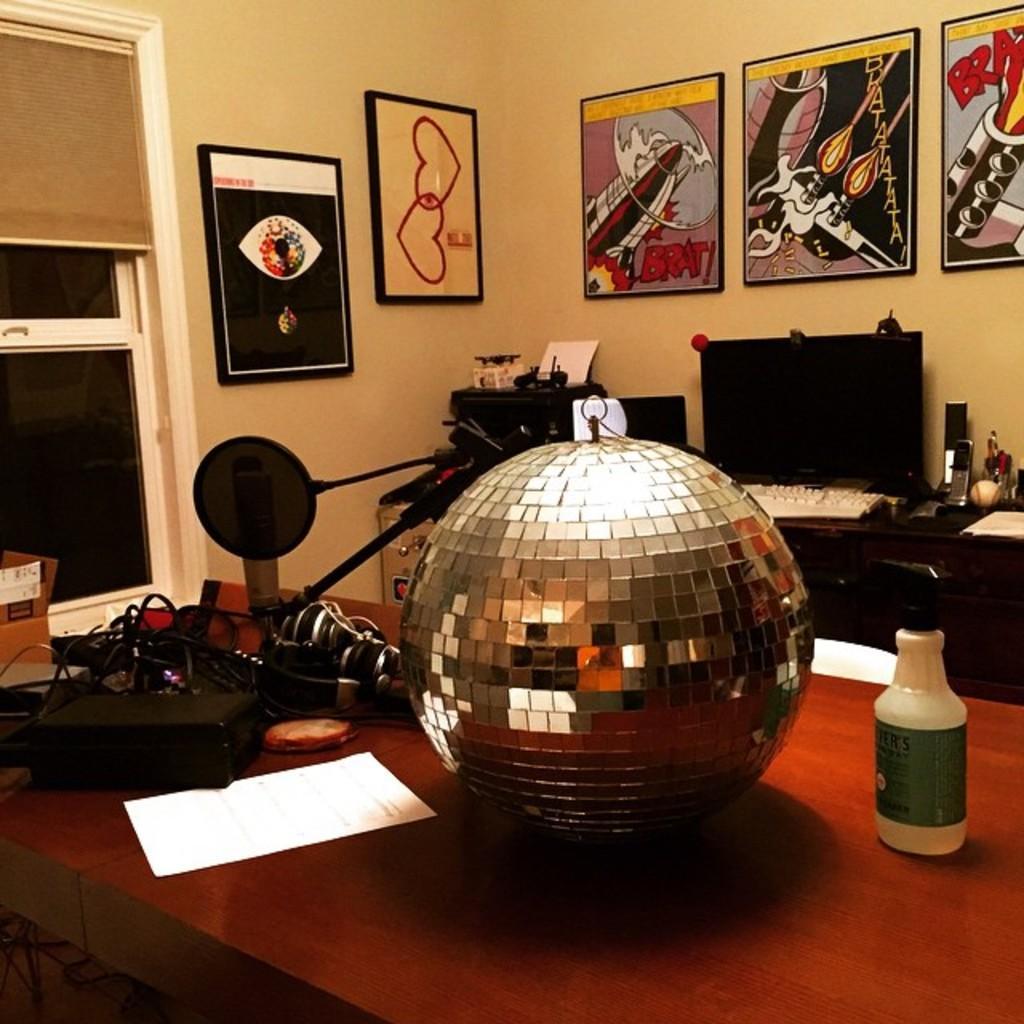Describe this image in one or two sentences. In this picture, There is a table which is in brown color on that table there is a golden color ball, There are some black color objects kept on the table, in the background there is a television which is in black color, There is a yellow color wall and there are some posters pasted on the wall. 